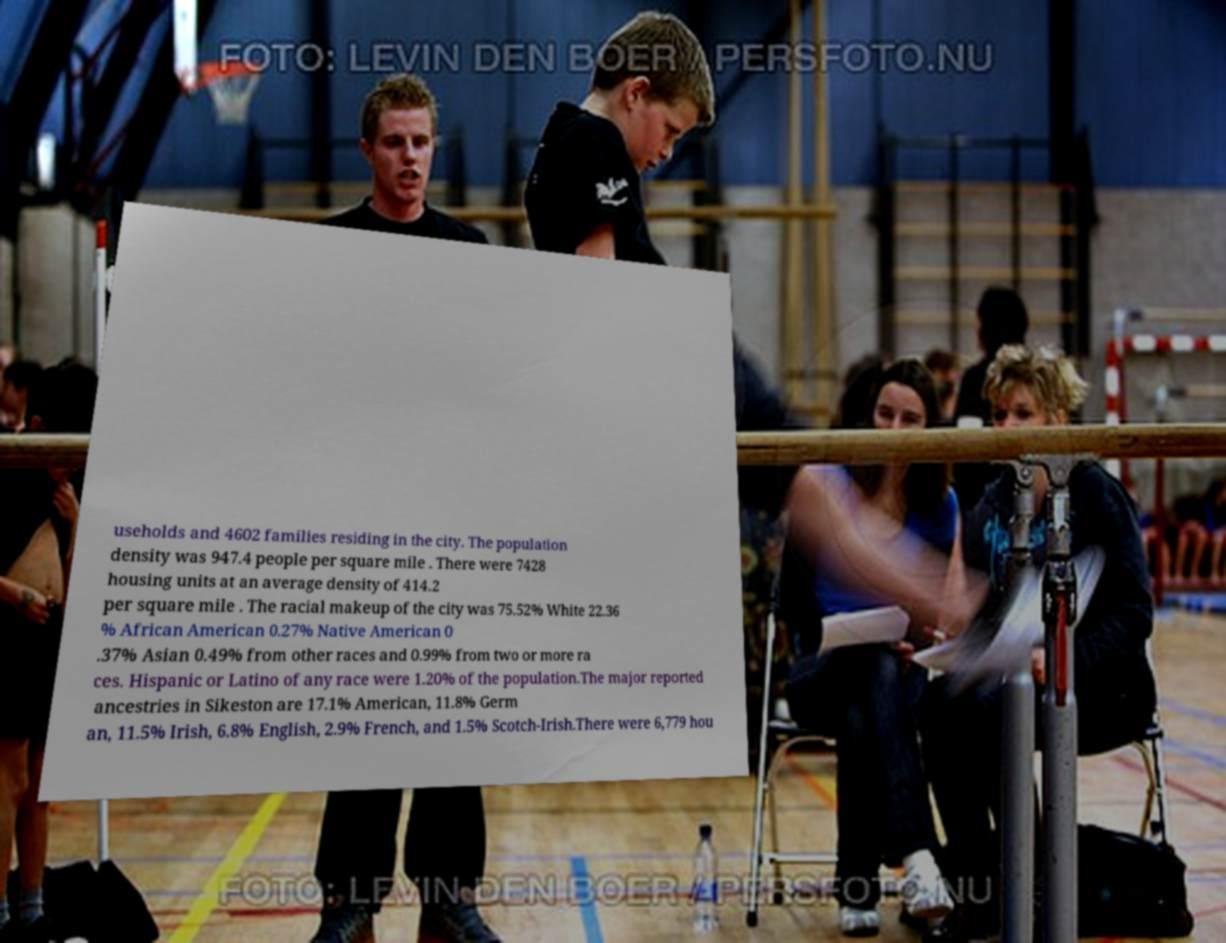For documentation purposes, I need the text within this image transcribed. Could you provide that? useholds and 4602 families residing in the city. The population density was 947.4 people per square mile . There were 7428 housing units at an average density of 414.2 per square mile . The racial makeup of the city was 75.52% White 22.36 % African American 0.27% Native American 0 .37% Asian 0.49% from other races and 0.99% from two or more ra ces. Hispanic or Latino of any race were 1.20% of the population.The major reported ancestries in Sikeston are 17.1% American, 11.8% Germ an, 11.5% Irish, 6.8% English, 2.9% French, and 1.5% Scotch-Irish.There were 6,779 hou 